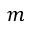Convert formula to latex. <formula><loc_0><loc_0><loc_500><loc_500>m</formula> 